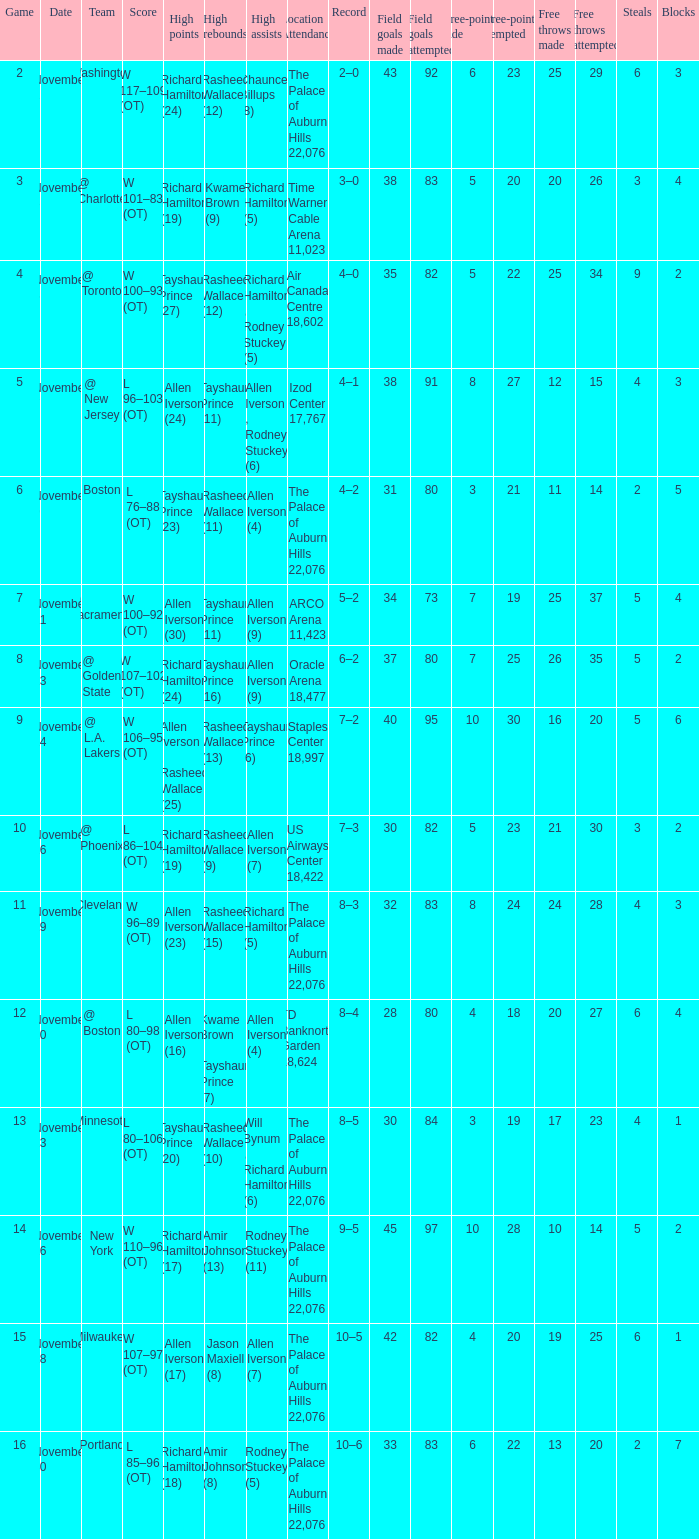What are the high points when the game has less than 10 points and chauncey billups has 8 high assists? Richard Hamilton (24). 